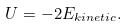Convert formula to latex. <formula><loc_0><loc_0><loc_500><loc_500>U = - 2 E _ { k i n e t i c } .</formula> 